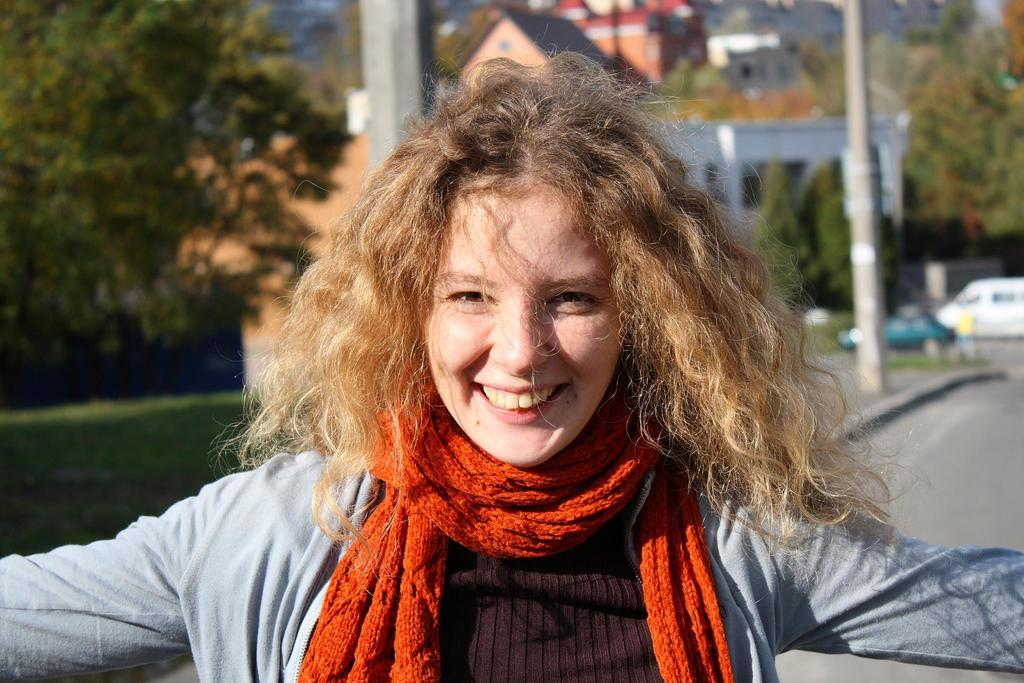Who is the main subject in the image? There is a woman in the image. What is the woman wearing around her neck? The woman is wearing an orange stole around her neck. What is the woman's facial expression? The woman is smiling. What can be seen in the background behind the woman? There are trees and houses behind the woman. What type of yam is being used as a prop in the image? There is no yam present in the image. Can you tell me how many sisters the woman has in the image? The provided facts do not mention any sisters, so it is impossible to determine the number of sisters the woman has in the image. 